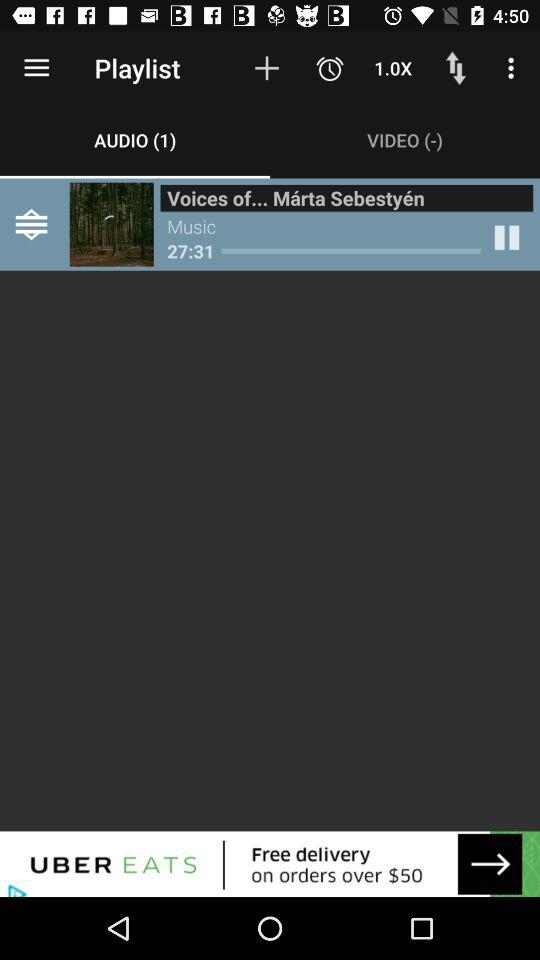How many episodes are in "docast.me"? There are 26 episodes in "docast.me". 